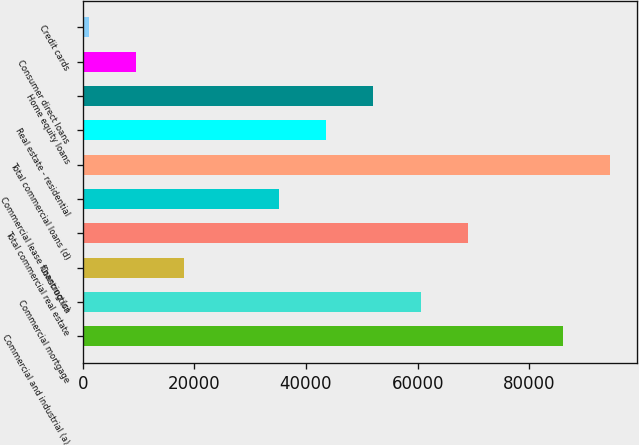Convert chart. <chart><loc_0><loc_0><loc_500><loc_500><bar_chart><fcel>Commercial and industrial (a)<fcel>Commercial mortgage<fcel>Construction<fcel>Total commercial real estate<fcel>Commercial lease financing (c)<fcel>Total commercial loans (d)<fcel>Real estate - residential<fcel>Home equity loans<fcel>Consumer direct loans<fcel>Credit cards<nl><fcel>86038<fcel>60559.9<fcel>18096.4<fcel>69052.6<fcel>35081.8<fcel>94530.7<fcel>43574.5<fcel>52067.2<fcel>9603.7<fcel>1111<nl></chart> 